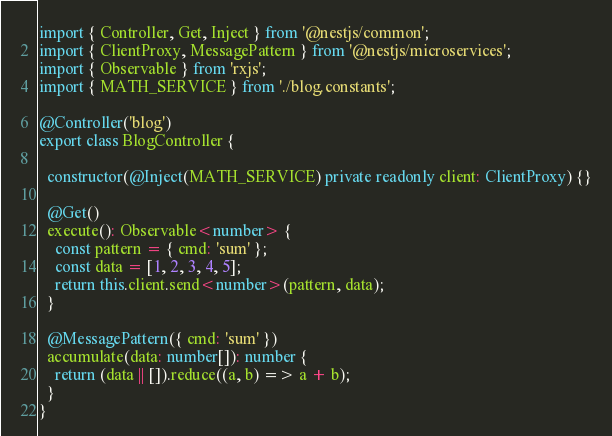Convert code to text. <code><loc_0><loc_0><loc_500><loc_500><_TypeScript_>import { Controller, Get, Inject } from '@nestjs/common';
import { ClientProxy, MessagePattern } from '@nestjs/microservices';
import { Observable } from 'rxjs';
import { MATH_SERVICE } from './blog.constants';

@Controller('blog')
export class BlogController {

  constructor(@Inject(MATH_SERVICE) private readonly client: ClientProxy) {}
  
  @Get()
  execute(): Observable<number> {
    const pattern = { cmd: 'sum' };
    const data = [1, 2, 3, 4, 5];
    return this.client.send<number>(pattern, data);
  }

  @MessagePattern({ cmd: 'sum' })
  accumulate(data: number[]): number {
    return (data || []).reduce((a, b) => a + b);
  }
}
</code> 